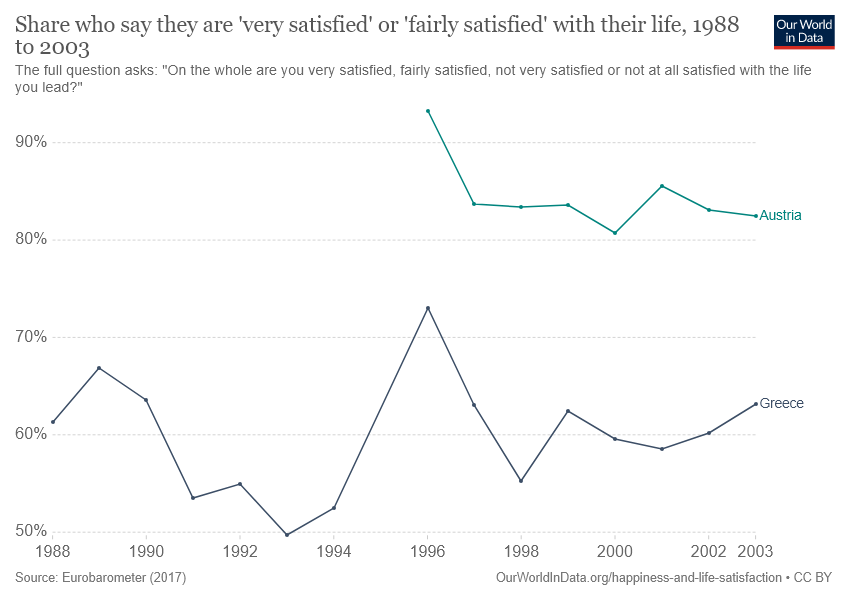List a handful of essential elements in this visual. The color of Austria is green. In the year 2000, the value of Austria was 0.22 higher than the value of Greece. 